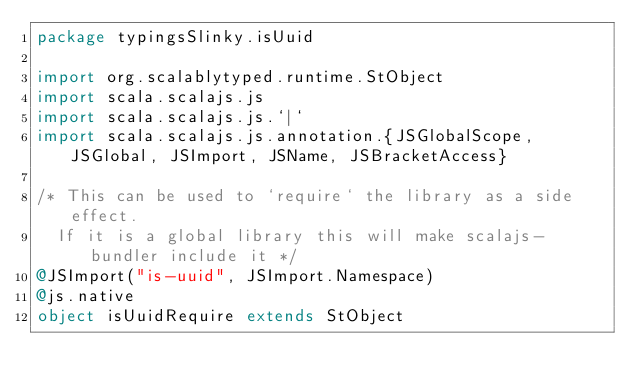<code> <loc_0><loc_0><loc_500><loc_500><_Scala_>package typingsSlinky.isUuid

import org.scalablytyped.runtime.StObject
import scala.scalajs.js
import scala.scalajs.js.`|`
import scala.scalajs.js.annotation.{JSGlobalScope, JSGlobal, JSImport, JSName, JSBracketAccess}

/* This can be used to `require` the library as a side effect.
  If it is a global library this will make scalajs-bundler include it */
@JSImport("is-uuid", JSImport.Namespace)
@js.native
object isUuidRequire extends StObject
</code> 